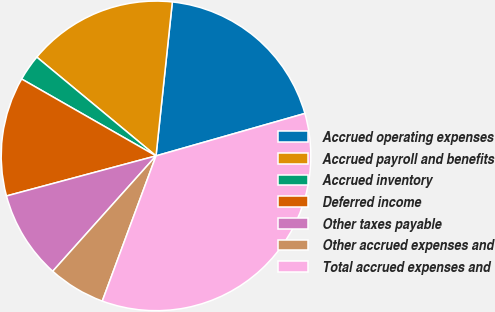Convert chart. <chart><loc_0><loc_0><loc_500><loc_500><pie_chart><fcel>Accrued operating expenses<fcel>Accrued payroll and benefits<fcel>Accrued inventory<fcel>Deferred income<fcel>Other taxes payable<fcel>Other accrued expenses and<fcel>Total accrued expenses and<nl><fcel>18.9%<fcel>15.67%<fcel>2.74%<fcel>12.44%<fcel>9.21%<fcel>5.98%<fcel>35.06%<nl></chart> 